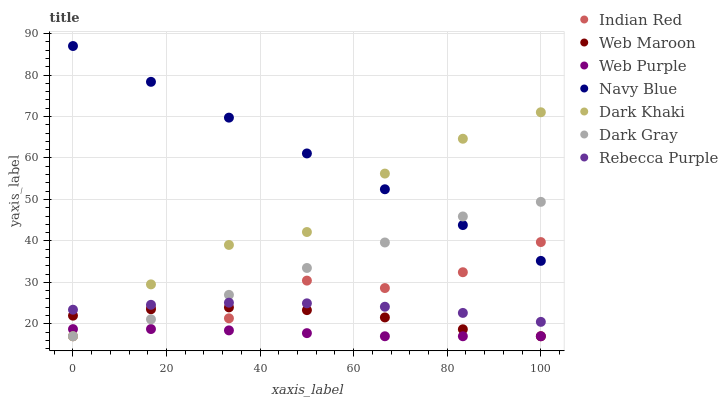Does Web Purple have the minimum area under the curve?
Answer yes or no. Yes. Does Navy Blue have the maximum area under the curve?
Answer yes or no. Yes. Does Web Maroon have the minimum area under the curve?
Answer yes or no. No. Does Web Maroon have the maximum area under the curve?
Answer yes or no. No. Is Navy Blue the smoothest?
Answer yes or no. Yes. Is Indian Red the roughest?
Answer yes or no. Yes. Is Web Maroon the smoothest?
Answer yes or no. No. Is Web Maroon the roughest?
Answer yes or no. No. Does Dark Gray have the lowest value?
Answer yes or no. Yes. Does Navy Blue have the lowest value?
Answer yes or no. No. Does Navy Blue have the highest value?
Answer yes or no. Yes. Does Web Maroon have the highest value?
Answer yes or no. No. Is Web Purple less than Navy Blue?
Answer yes or no. Yes. Is Rebecca Purple greater than Web Purple?
Answer yes or no. Yes. Does Navy Blue intersect Indian Red?
Answer yes or no. Yes. Is Navy Blue less than Indian Red?
Answer yes or no. No. Is Navy Blue greater than Indian Red?
Answer yes or no. No. Does Web Purple intersect Navy Blue?
Answer yes or no. No. 